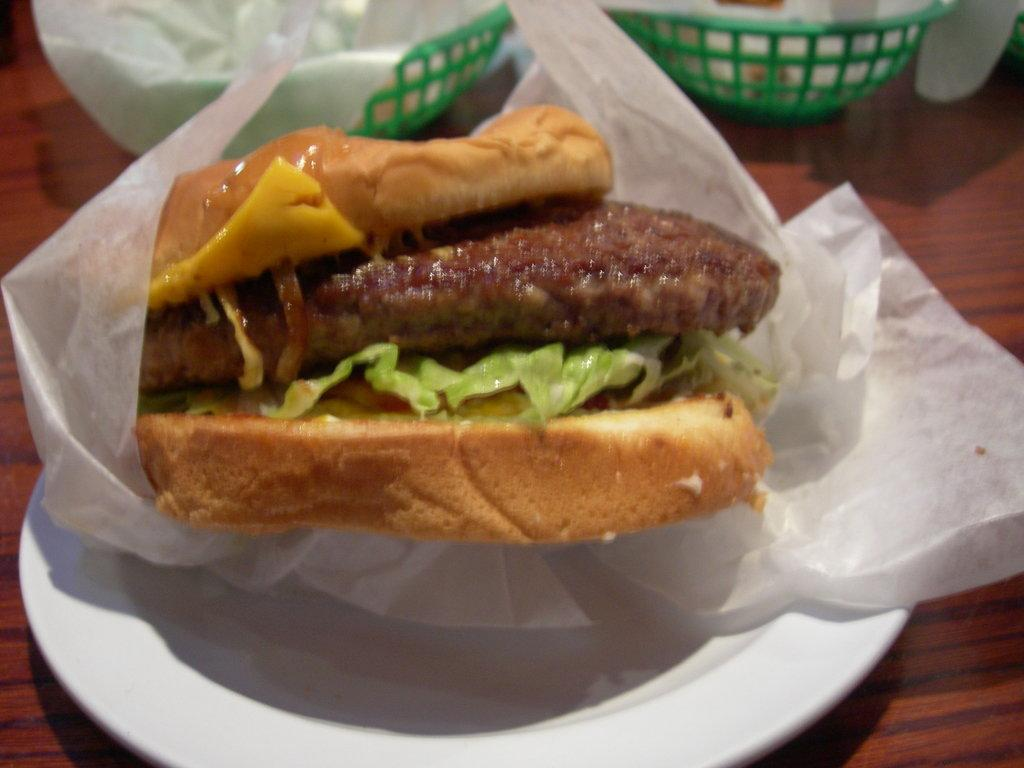What is the main food item visible in the image? There is a food item in a plate in the image. Can you describe any other objects present on the table in the image? Unfortunately, the provided facts do not specify any other objects on the table in the image. What type of maid is serving the food in the image? There is no maid present in the image. How many times does the father appear in the image? There is no father present in the image. 